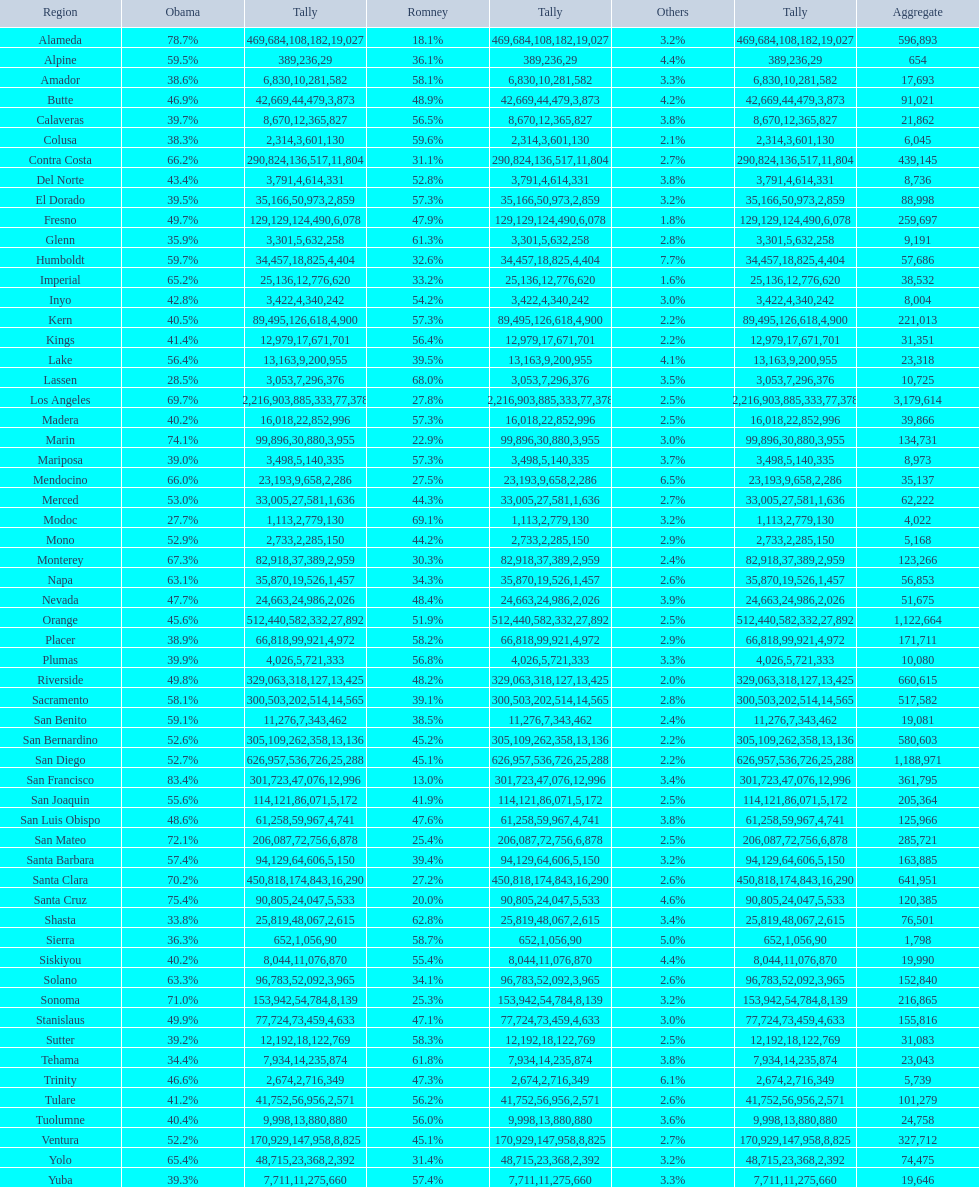What county is just before del norte on the list? Contra Costa. 